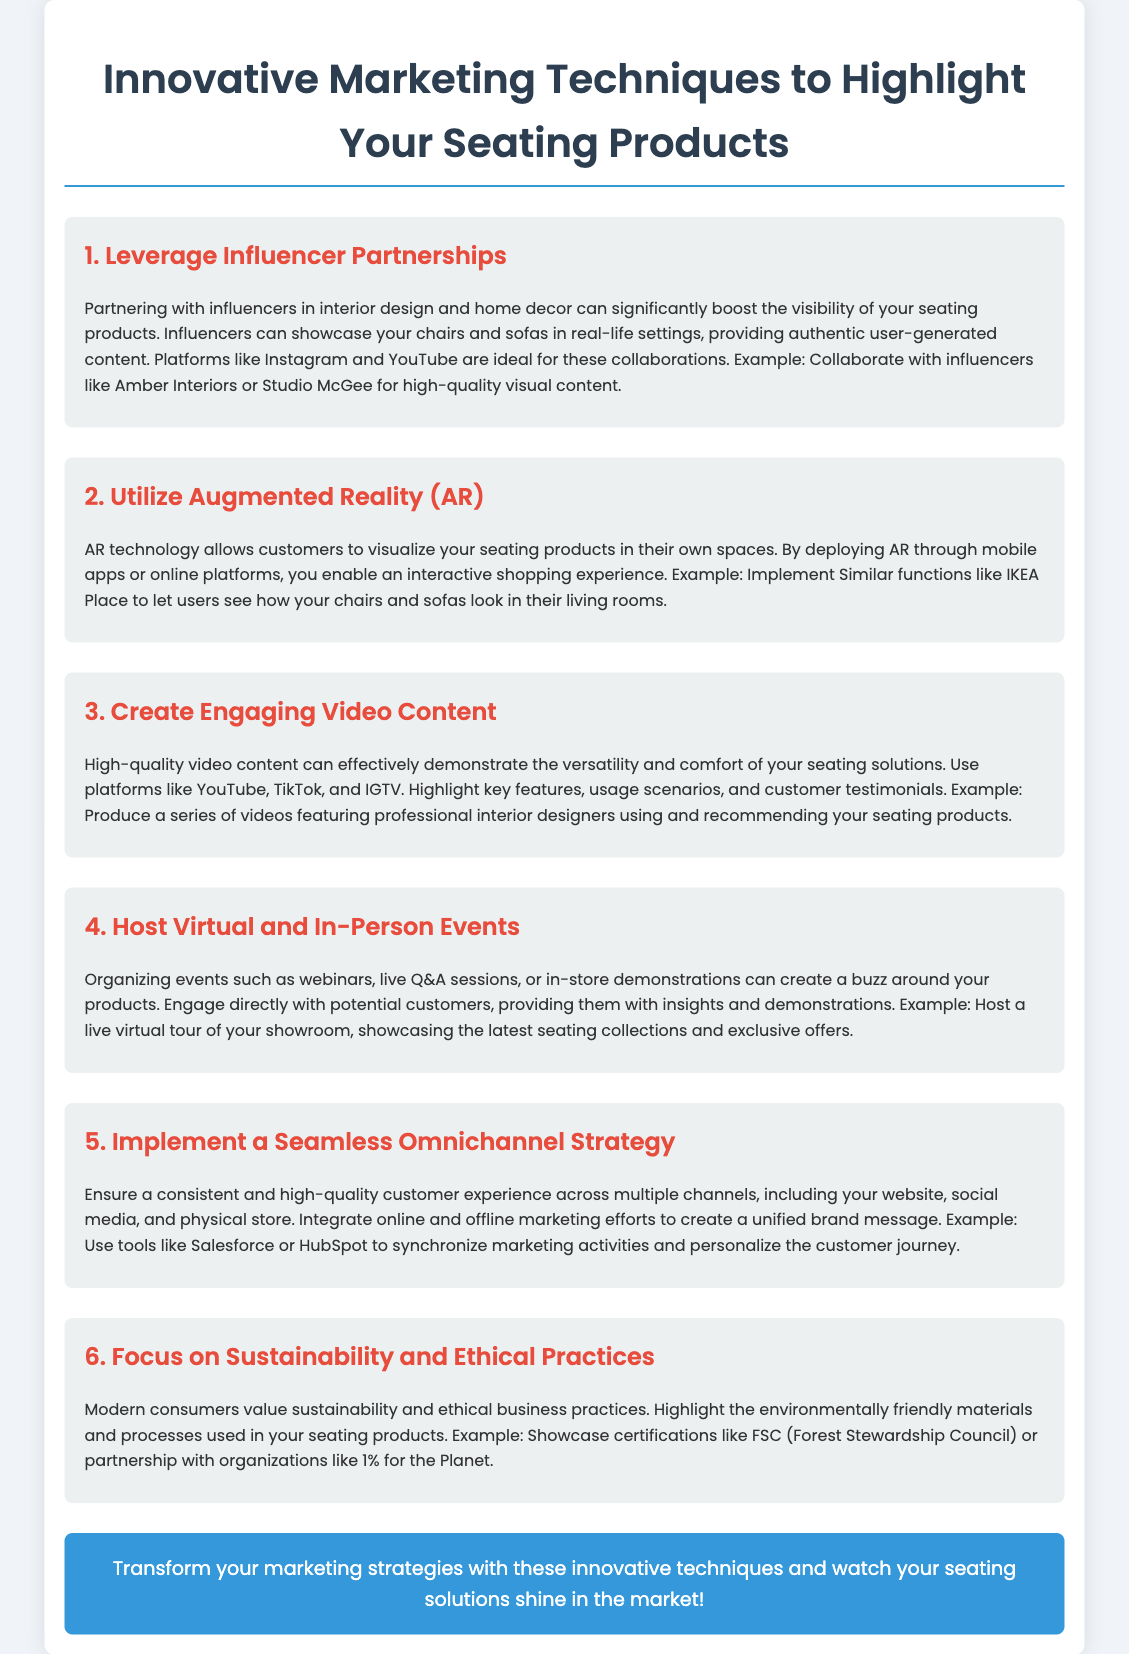What is the title of the document? The document title is prominently displayed at the top of the flyer.
Answer: Innovative Marketing Techniques to Highlight Your Seating Products How many marketing techniques are listed in the document? The document lists a total of six different marketing techniques for seating products.
Answer: 6 What is one example of leveraging influencer partnerships? The document specifies a couple of influencer examples for showcasing seating products.
Answer: Amber Interiors What technology is suggested for customers to visualize seating products? The document discusses using a specific technology to enhance the shopping experience.
Answer: Augmented Reality (AR) What type of content can effectively demonstrate seating solutions? The document mentions a certain type of content as effective for showcasing product features.
Answer: Video Content Which platform is suggested for hosting live events? The document suggests a platform for organizing engaging interactions with potential customers.
Answer: Virtual What should you focus on to appeal to modern consumers? The document advises on key values that resonate with today's customers.
Answer: Sustainability and Ethical Practices Which marketing tool is mentioned for synchronizing activities? The document refers to a tool that can help streamline marketing efforts across channels.
Answer: Salesforce 